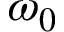<formula> <loc_0><loc_0><loc_500><loc_500>\omega _ { 0 }</formula> 